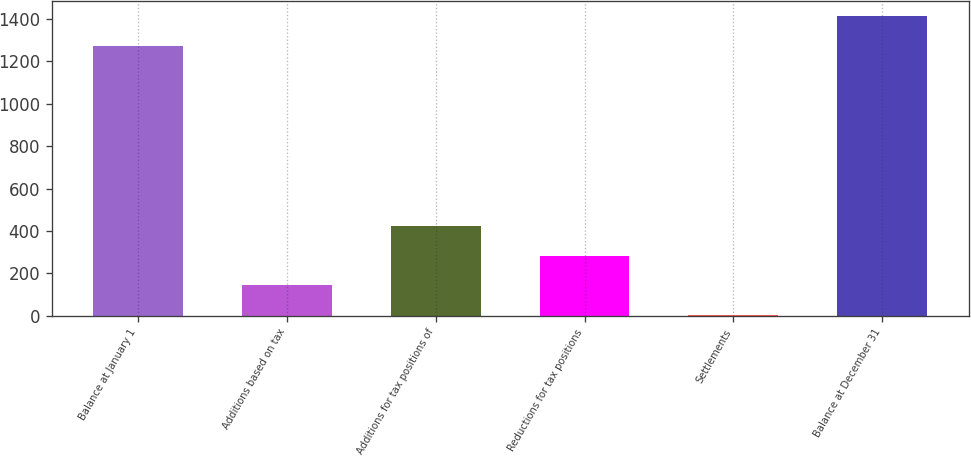Convert chart. <chart><loc_0><loc_0><loc_500><loc_500><bar_chart><fcel>Balance at January 1<fcel>Additions based on tax<fcel>Additions for tax positions of<fcel>Reductions for tax positions<fcel>Settlements<fcel>Balance at December 31<nl><fcel>1274<fcel>142.7<fcel>422.1<fcel>282.4<fcel>3<fcel>1413.7<nl></chart> 